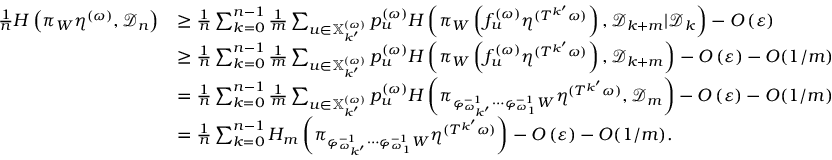Convert formula to latex. <formula><loc_0><loc_0><loc_500><loc_500>\begin{array} { r l } { \frac { 1 } { n } H \left ( \pi _ { W } \eta ^ { ( \omega ) } , { \mathcal { D } } _ { n } \right ) } & { \geq \frac { 1 } { n } \sum _ { k = 0 } ^ { n - 1 } \frac { 1 } { m } \sum _ { u \in \mathbb { X } _ { k ^ { \prime } } ^ { ( \omega ) } } p _ { u } ^ { ( \omega ) } H \left ( \pi _ { W } \left ( f _ { u } ^ { ( \omega ) } \eta ^ { ( T ^ { k ^ { \prime } } \omega ) } \right ) , { \mathcal { D } } _ { k + m } | { \mathcal { D } } _ { k } \right ) - O \left ( \varepsilon \right ) } \\ & { \geq \frac { 1 } { n } \sum _ { k = 0 } ^ { n - 1 } \frac { 1 } { m } \sum _ { u \in \mathbb { X } _ { k ^ { \prime } } ^ { ( \omega ) } } p _ { u } ^ { ( \omega ) } H \left ( \pi _ { W } \left ( f _ { u } ^ { ( \omega ) } \eta ^ { ( T ^ { k ^ { \prime } } \omega ) } \right ) , { \mathcal { D } } _ { k + m } \right ) - O \left ( \varepsilon \right ) - O ( 1 / m ) } \\ & { = \frac { 1 } { n } \sum _ { k = 0 } ^ { n - 1 } \frac { 1 } { m } \sum _ { u \in \mathbb { X } _ { k ^ { \prime } } ^ { ( \omega ) } } p _ { u } ^ { ( \omega ) } H \left ( \pi _ { \varphi _ { \omega _ { k ^ { \prime } } } ^ { - 1 } \cdots \varphi _ { \omega _ { 1 } } ^ { - 1 } W } \eta ^ { ( T ^ { k ^ { \prime } } \omega ) } , { \mathcal { D } } _ { m } \right ) - O \left ( \varepsilon \right ) - O ( 1 / m ) } \\ & { = \frac { 1 } { n } \sum _ { k = 0 } ^ { n - 1 } H _ { m } \left ( \pi _ { \varphi _ { \omega _ { k ^ { \prime } } } ^ { - 1 } \cdots \varphi _ { \omega _ { 1 } } ^ { - 1 } W } \eta ^ { ( T ^ { k ^ { \prime } } \omega ) } \right ) - O \left ( \varepsilon \right ) - O ( 1 / m ) . } \end{array}</formula> 